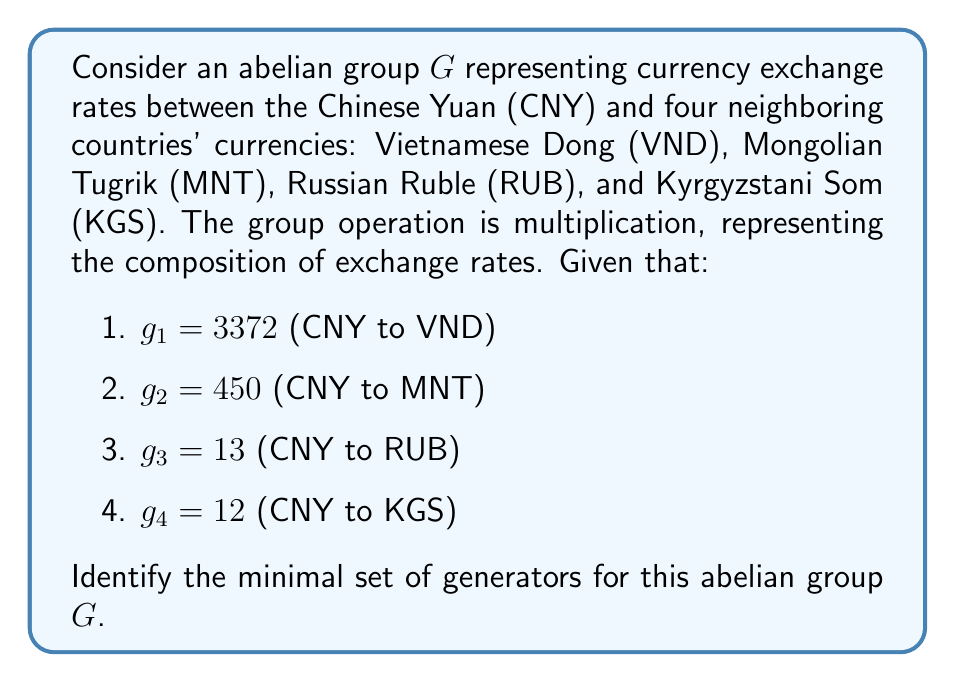Provide a solution to this math problem. To solve this problem, we need to follow these steps:

1. Recognize that the group $G$ is isomorphic to $(\mathbb{Z}_+, +)$, the group of positive integers under addition, because currency exchange rates are positive rational numbers.

2. Convert the problem to finding the generators of the additive group of integers generated by $\{3372, 450, 13, 12\}$.

3. To find the minimal set of generators, we need to find the greatest common divisor (GCD) of all the elements:

   $GCD(3372, 450, 13, 12) = GCD(GCD(3372, 450), GCD(13, 12))$

4. Calculate step by step:
   
   $GCD(3372, 450) = GCD(450, 72) = GCD(72, 18) = GCD(18, 0) = 18$
   
   $GCD(13, 12) = GCD(12, 1) = 1$
   
   $GCD(18, 1) = 1$

5. The GCD of all elements is 1, which means that the subgroup generated by these elements is the entire group of integers.

6. However, we need to find the minimal set of generators. We can eliminate 3372 and 450 as they are multiples of 18:

   $3372 = 18 \times 187$
   $450 = 18 \times 25$

7. We're left with $\{18, 13, 12\}$. We can further eliminate 18 as it can be generated by 12 and 13:

   $18 = 13 + 5 = 13 + 12 - 7 = 2 \times 13 - 12 + 4 = 3 \times 13 - 2 \times 12 - 1$

Therefore, the minimal set of generators for the group is $\{13, 12\}$, corresponding to the Russian Ruble (RUB) and Kyrgyzstani Som (KGS) exchange rates.
Answer: The minimal set of generators for the abelian group $G$ representing the currency exchange rates is $\{g_3, g_4\}$, corresponding to the exchange rates for the Russian Ruble (RUB) and Kyrgyzstani Som (KGS). 